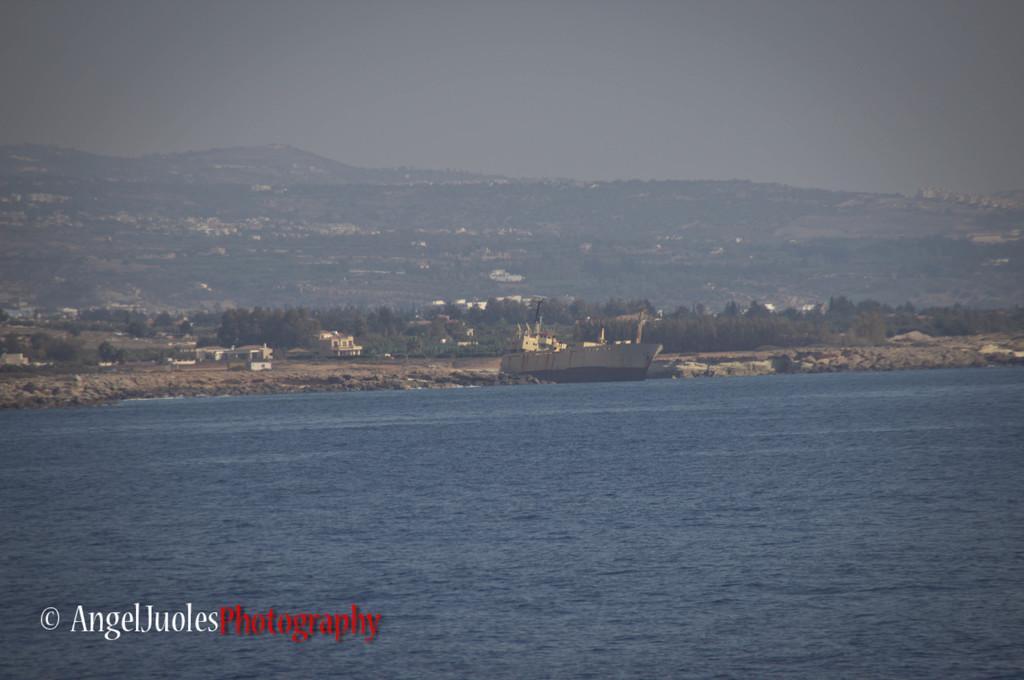Could you give a brief overview of what you see in this image? In this picture I can see a ship on the water. I can see buildings, trees, hills, and in the background there is the sky and there is a watermark on the image. 